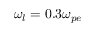Convert formula to latex. <formula><loc_0><loc_0><loc_500><loc_500>\omega _ { l } = 0 . 3 \omega _ { p e }</formula> 